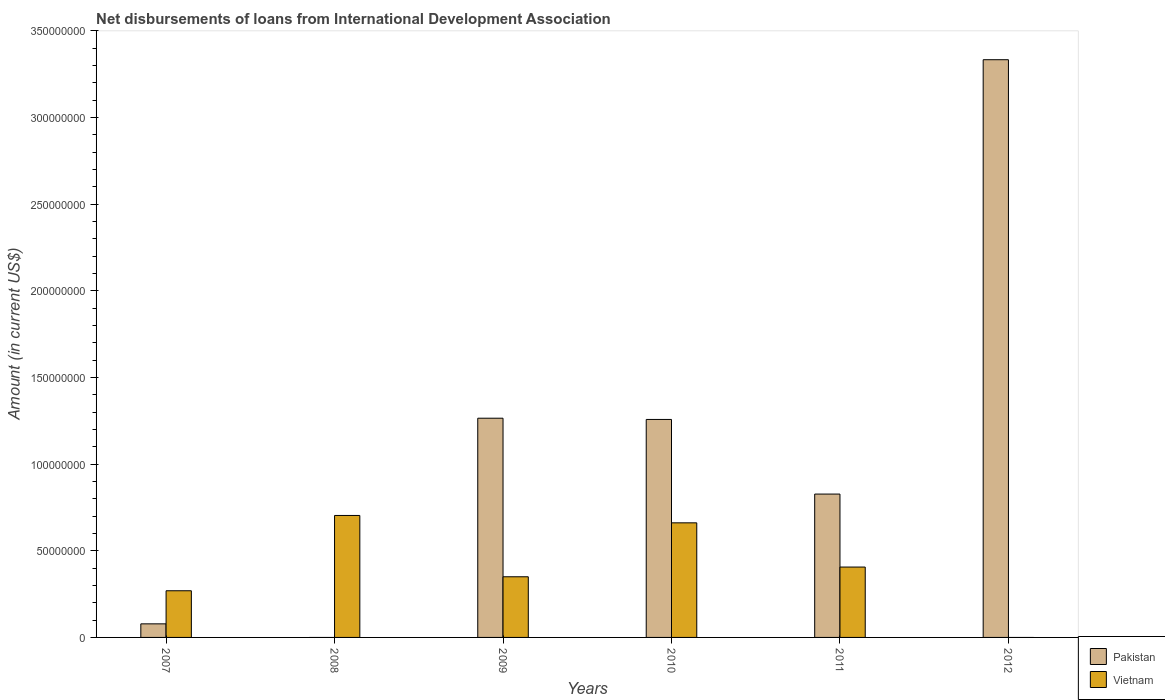How many bars are there on the 4th tick from the left?
Make the answer very short. 2. What is the amount of loans disbursed in Pakistan in 2010?
Make the answer very short. 1.26e+08. Across all years, what is the maximum amount of loans disbursed in Vietnam?
Provide a short and direct response. 7.04e+07. Across all years, what is the minimum amount of loans disbursed in Vietnam?
Your answer should be compact. 0. In which year was the amount of loans disbursed in Vietnam maximum?
Keep it short and to the point. 2008. What is the total amount of loans disbursed in Pakistan in the graph?
Make the answer very short. 6.76e+08. What is the difference between the amount of loans disbursed in Pakistan in 2010 and that in 2012?
Your answer should be very brief. -2.08e+08. What is the difference between the amount of loans disbursed in Vietnam in 2007 and the amount of loans disbursed in Pakistan in 2009?
Your response must be concise. -9.96e+07. What is the average amount of loans disbursed in Vietnam per year?
Your answer should be compact. 3.98e+07. In the year 2011, what is the difference between the amount of loans disbursed in Vietnam and amount of loans disbursed in Pakistan?
Ensure brevity in your answer.  -4.21e+07. What is the ratio of the amount of loans disbursed in Pakistan in 2010 to that in 2012?
Make the answer very short. 0.38. What is the difference between the highest and the second highest amount of loans disbursed in Vietnam?
Keep it short and to the point. 4.26e+06. What is the difference between the highest and the lowest amount of loans disbursed in Pakistan?
Offer a terse response. 3.33e+08. In how many years, is the amount of loans disbursed in Pakistan greater than the average amount of loans disbursed in Pakistan taken over all years?
Give a very brief answer. 3. Is the sum of the amount of loans disbursed in Pakistan in 2009 and 2010 greater than the maximum amount of loans disbursed in Vietnam across all years?
Keep it short and to the point. Yes. Are all the bars in the graph horizontal?
Your answer should be very brief. No. What is the difference between two consecutive major ticks on the Y-axis?
Give a very brief answer. 5.00e+07. Are the values on the major ticks of Y-axis written in scientific E-notation?
Give a very brief answer. No. Does the graph contain any zero values?
Keep it short and to the point. Yes. How many legend labels are there?
Offer a very short reply. 2. What is the title of the graph?
Provide a succinct answer. Net disbursements of loans from International Development Association. Does "Chad" appear as one of the legend labels in the graph?
Provide a short and direct response. No. What is the label or title of the X-axis?
Offer a terse response. Years. What is the Amount (in current US$) of Pakistan in 2007?
Provide a succinct answer. 7.84e+06. What is the Amount (in current US$) of Vietnam in 2007?
Make the answer very short. 2.69e+07. What is the Amount (in current US$) of Pakistan in 2008?
Your answer should be compact. 0. What is the Amount (in current US$) in Vietnam in 2008?
Provide a succinct answer. 7.04e+07. What is the Amount (in current US$) in Pakistan in 2009?
Provide a short and direct response. 1.26e+08. What is the Amount (in current US$) in Vietnam in 2009?
Provide a succinct answer. 3.50e+07. What is the Amount (in current US$) in Pakistan in 2010?
Your answer should be very brief. 1.26e+08. What is the Amount (in current US$) in Vietnam in 2010?
Your answer should be very brief. 6.61e+07. What is the Amount (in current US$) in Pakistan in 2011?
Make the answer very short. 8.27e+07. What is the Amount (in current US$) in Vietnam in 2011?
Provide a short and direct response. 4.06e+07. What is the Amount (in current US$) of Pakistan in 2012?
Provide a short and direct response. 3.33e+08. What is the Amount (in current US$) in Vietnam in 2012?
Offer a very short reply. 0. Across all years, what is the maximum Amount (in current US$) in Pakistan?
Provide a short and direct response. 3.33e+08. Across all years, what is the maximum Amount (in current US$) in Vietnam?
Keep it short and to the point. 7.04e+07. Across all years, what is the minimum Amount (in current US$) of Pakistan?
Keep it short and to the point. 0. What is the total Amount (in current US$) of Pakistan in the graph?
Keep it short and to the point. 6.76e+08. What is the total Amount (in current US$) in Vietnam in the graph?
Your answer should be very brief. 2.39e+08. What is the difference between the Amount (in current US$) of Vietnam in 2007 and that in 2008?
Offer a very short reply. -4.35e+07. What is the difference between the Amount (in current US$) in Pakistan in 2007 and that in 2009?
Your response must be concise. -1.19e+08. What is the difference between the Amount (in current US$) in Vietnam in 2007 and that in 2009?
Your answer should be compact. -8.08e+06. What is the difference between the Amount (in current US$) in Pakistan in 2007 and that in 2010?
Ensure brevity in your answer.  -1.18e+08. What is the difference between the Amount (in current US$) of Vietnam in 2007 and that in 2010?
Provide a short and direct response. -3.92e+07. What is the difference between the Amount (in current US$) in Pakistan in 2007 and that in 2011?
Offer a terse response. -7.49e+07. What is the difference between the Amount (in current US$) in Vietnam in 2007 and that in 2011?
Provide a short and direct response. -1.37e+07. What is the difference between the Amount (in current US$) in Pakistan in 2007 and that in 2012?
Ensure brevity in your answer.  -3.26e+08. What is the difference between the Amount (in current US$) of Vietnam in 2008 and that in 2009?
Offer a very short reply. 3.54e+07. What is the difference between the Amount (in current US$) of Vietnam in 2008 and that in 2010?
Your answer should be very brief. 4.26e+06. What is the difference between the Amount (in current US$) of Vietnam in 2008 and that in 2011?
Your answer should be compact. 2.98e+07. What is the difference between the Amount (in current US$) in Pakistan in 2009 and that in 2010?
Your response must be concise. 7.15e+05. What is the difference between the Amount (in current US$) of Vietnam in 2009 and that in 2010?
Your answer should be compact. -3.11e+07. What is the difference between the Amount (in current US$) in Pakistan in 2009 and that in 2011?
Provide a succinct answer. 4.38e+07. What is the difference between the Amount (in current US$) of Vietnam in 2009 and that in 2011?
Provide a short and direct response. -5.61e+06. What is the difference between the Amount (in current US$) of Pakistan in 2009 and that in 2012?
Offer a terse response. -2.07e+08. What is the difference between the Amount (in current US$) of Pakistan in 2010 and that in 2011?
Your response must be concise. 4.31e+07. What is the difference between the Amount (in current US$) of Vietnam in 2010 and that in 2011?
Keep it short and to the point. 2.55e+07. What is the difference between the Amount (in current US$) of Pakistan in 2010 and that in 2012?
Provide a succinct answer. -2.08e+08. What is the difference between the Amount (in current US$) in Pakistan in 2011 and that in 2012?
Offer a terse response. -2.51e+08. What is the difference between the Amount (in current US$) of Pakistan in 2007 and the Amount (in current US$) of Vietnam in 2008?
Your answer should be compact. -6.25e+07. What is the difference between the Amount (in current US$) of Pakistan in 2007 and the Amount (in current US$) of Vietnam in 2009?
Your answer should be compact. -2.72e+07. What is the difference between the Amount (in current US$) of Pakistan in 2007 and the Amount (in current US$) of Vietnam in 2010?
Your answer should be compact. -5.83e+07. What is the difference between the Amount (in current US$) in Pakistan in 2007 and the Amount (in current US$) in Vietnam in 2011?
Provide a succinct answer. -3.28e+07. What is the difference between the Amount (in current US$) in Pakistan in 2009 and the Amount (in current US$) in Vietnam in 2010?
Provide a short and direct response. 6.04e+07. What is the difference between the Amount (in current US$) in Pakistan in 2009 and the Amount (in current US$) in Vietnam in 2011?
Give a very brief answer. 8.59e+07. What is the difference between the Amount (in current US$) in Pakistan in 2010 and the Amount (in current US$) in Vietnam in 2011?
Offer a terse response. 8.52e+07. What is the average Amount (in current US$) in Pakistan per year?
Your answer should be compact. 1.13e+08. What is the average Amount (in current US$) in Vietnam per year?
Make the answer very short. 3.98e+07. In the year 2007, what is the difference between the Amount (in current US$) in Pakistan and Amount (in current US$) in Vietnam?
Your response must be concise. -1.91e+07. In the year 2009, what is the difference between the Amount (in current US$) in Pakistan and Amount (in current US$) in Vietnam?
Provide a succinct answer. 9.15e+07. In the year 2010, what is the difference between the Amount (in current US$) in Pakistan and Amount (in current US$) in Vietnam?
Provide a short and direct response. 5.97e+07. In the year 2011, what is the difference between the Amount (in current US$) of Pakistan and Amount (in current US$) of Vietnam?
Your answer should be compact. 4.21e+07. What is the ratio of the Amount (in current US$) of Vietnam in 2007 to that in 2008?
Give a very brief answer. 0.38. What is the ratio of the Amount (in current US$) in Pakistan in 2007 to that in 2009?
Keep it short and to the point. 0.06. What is the ratio of the Amount (in current US$) in Vietnam in 2007 to that in 2009?
Your response must be concise. 0.77. What is the ratio of the Amount (in current US$) of Pakistan in 2007 to that in 2010?
Ensure brevity in your answer.  0.06. What is the ratio of the Amount (in current US$) of Vietnam in 2007 to that in 2010?
Offer a very short reply. 0.41. What is the ratio of the Amount (in current US$) of Pakistan in 2007 to that in 2011?
Provide a short and direct response. 0.09. What is the ratio of the Amount (in current US$) of Vietnam in 2007 to that in 2011?
Offer a very short reply. 0.66. What is the ratio of the Amount (in current US$) of Pakistan in 2007 to that in 2012?
Offer a terse response. 0.02. What is the ratio of the Amount (in current US$) of Vietnam in 2008 to that in 2009?
Offer a terse response. 2.01. What is the ratio of the Amount (in current US$) of Vietnam in 2008 to that in 2010?
Provide a succinct answer. 1.06. What is the ratio of the Amount (in current US$) of Vietnam in 2008 to that in 2011?
Provide a succinct answer. 1.73. What is the ratio of the Amount (in current US$) of Pakistan in 2009 to that in 2010?
Provide a succinct answer. 1.01. What is the ratio of the Amount (in current US$) of Vietnam in 2009 to that in 2010?
Your response must be concise. 0.53. What is the ratio of the Amount (in current US$) of Pakistan in 2009 to that in 2011?
Your answer should be compact. 1.53. What is the ratio of the Amount (in current US$) of Vietnam in 2009 to that in 2011?
Your answer should be very brief. 0.86. What is the ratio of the Amount (in current US$) of Pakistan in 2009 to that in 2012?
Provide a succinct answer. 0.38. What is the ratio of the Amount (in current US$) of Pakistan in 2010 to that in 2011?
Give a very brief answer. 1.52. What is the ratio of the Amount (in current US$) in Vietnam in 2010 to that in 2011?
Make the answer very short. 1.63. What is the ratio of the Amount (in current US$) of Pakistan in 2010 to that in 2012?
Your answer should be very brief. 0.38. What is the ratio of the Amount (in current US$) in Pakistan in 2011 to that in 2012?
Give a very brief answer. 0.25. What is the difference between the highest and the second highest Amount (in current US$) in Pakistan?
Your response must be concise. 2.07e+08. What is the difference between the highest and the second highest Amount (in current US$) in Vietnam?
Provide a succinct answer. 4.26e+06. What is the difference between the highest and the lowest Amount (in current US$) of Pakistan?
Give a very brief answer. 3.33e+08. What is the difference between the highest and the lowest Amount (in current US$) of Vietnam?
Your answer should be very brief. 7.04e+07. 